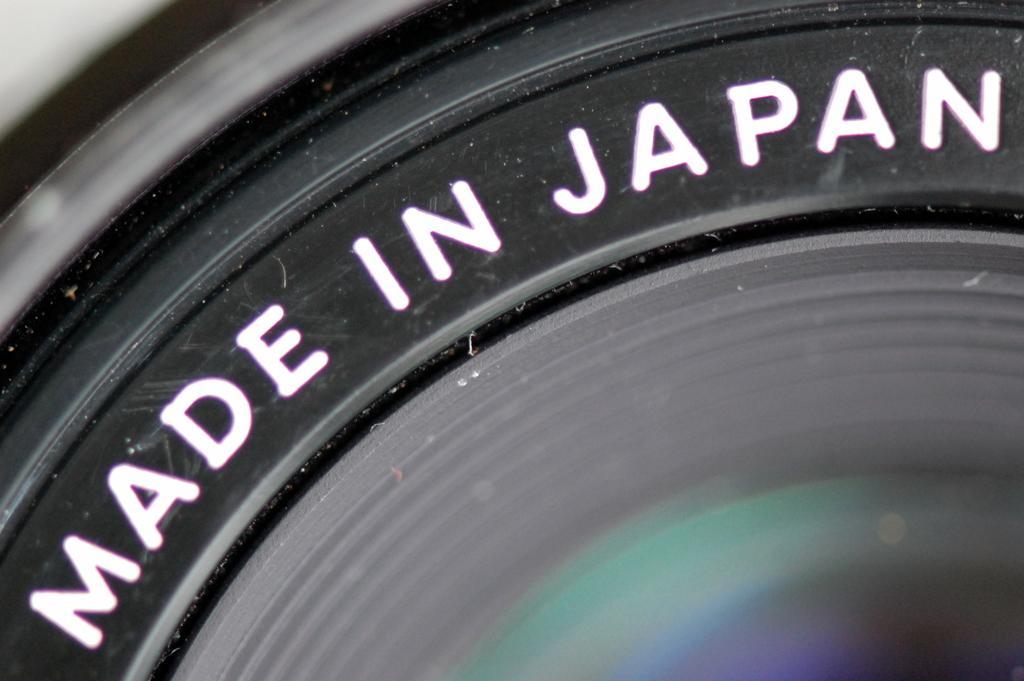Can you describe this image briefly? This picture looks like a lens of a camera and I can see text on it. 